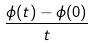Convert formula to latex. <formula><loc_0><loc_0><loc_500><loc_500>\frac { \phi ( t ) - \phi ( 0 ) } { t }</formula> 